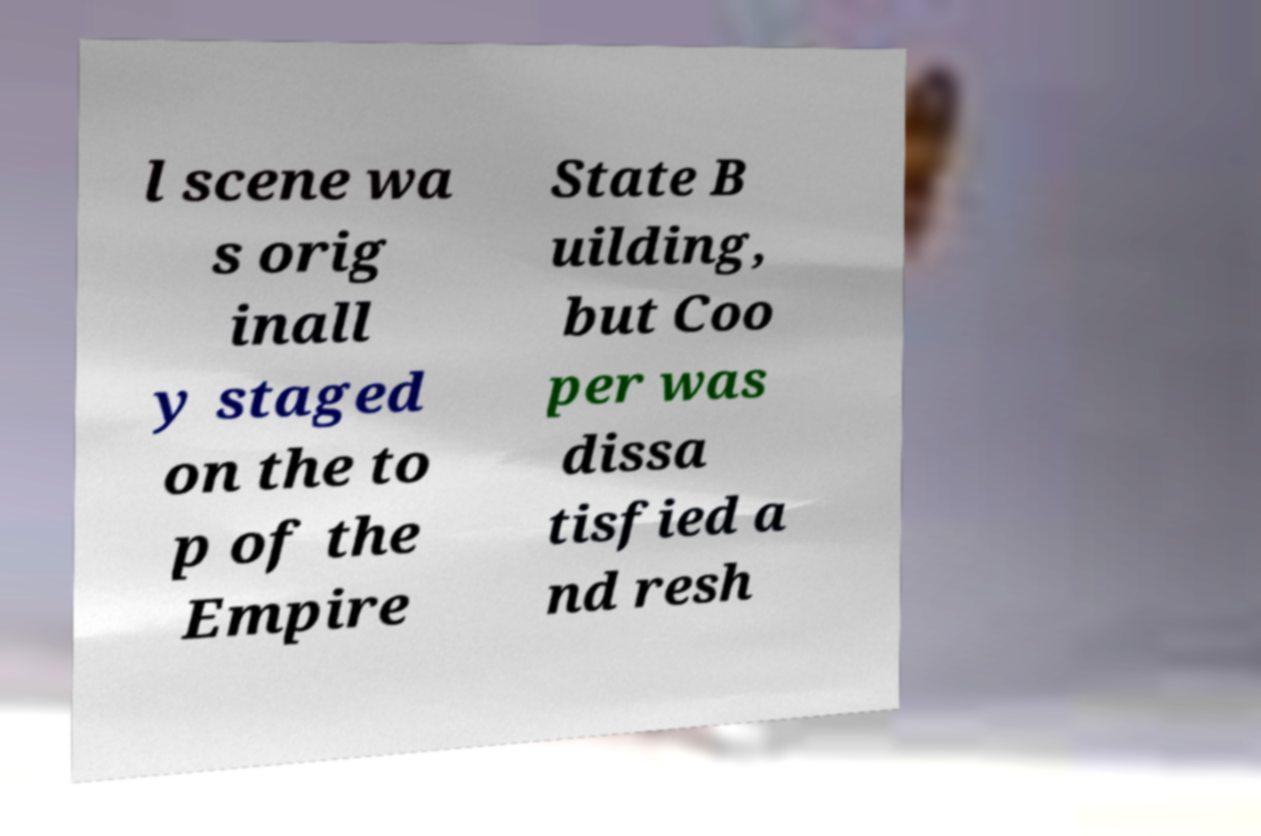Could you assist in decoding the text presented in this image and type it out clearly? l scene wa s orig inall y staged on the to p of the Empire State B uilding, but Coo per was dissa tisfied a nd resh 